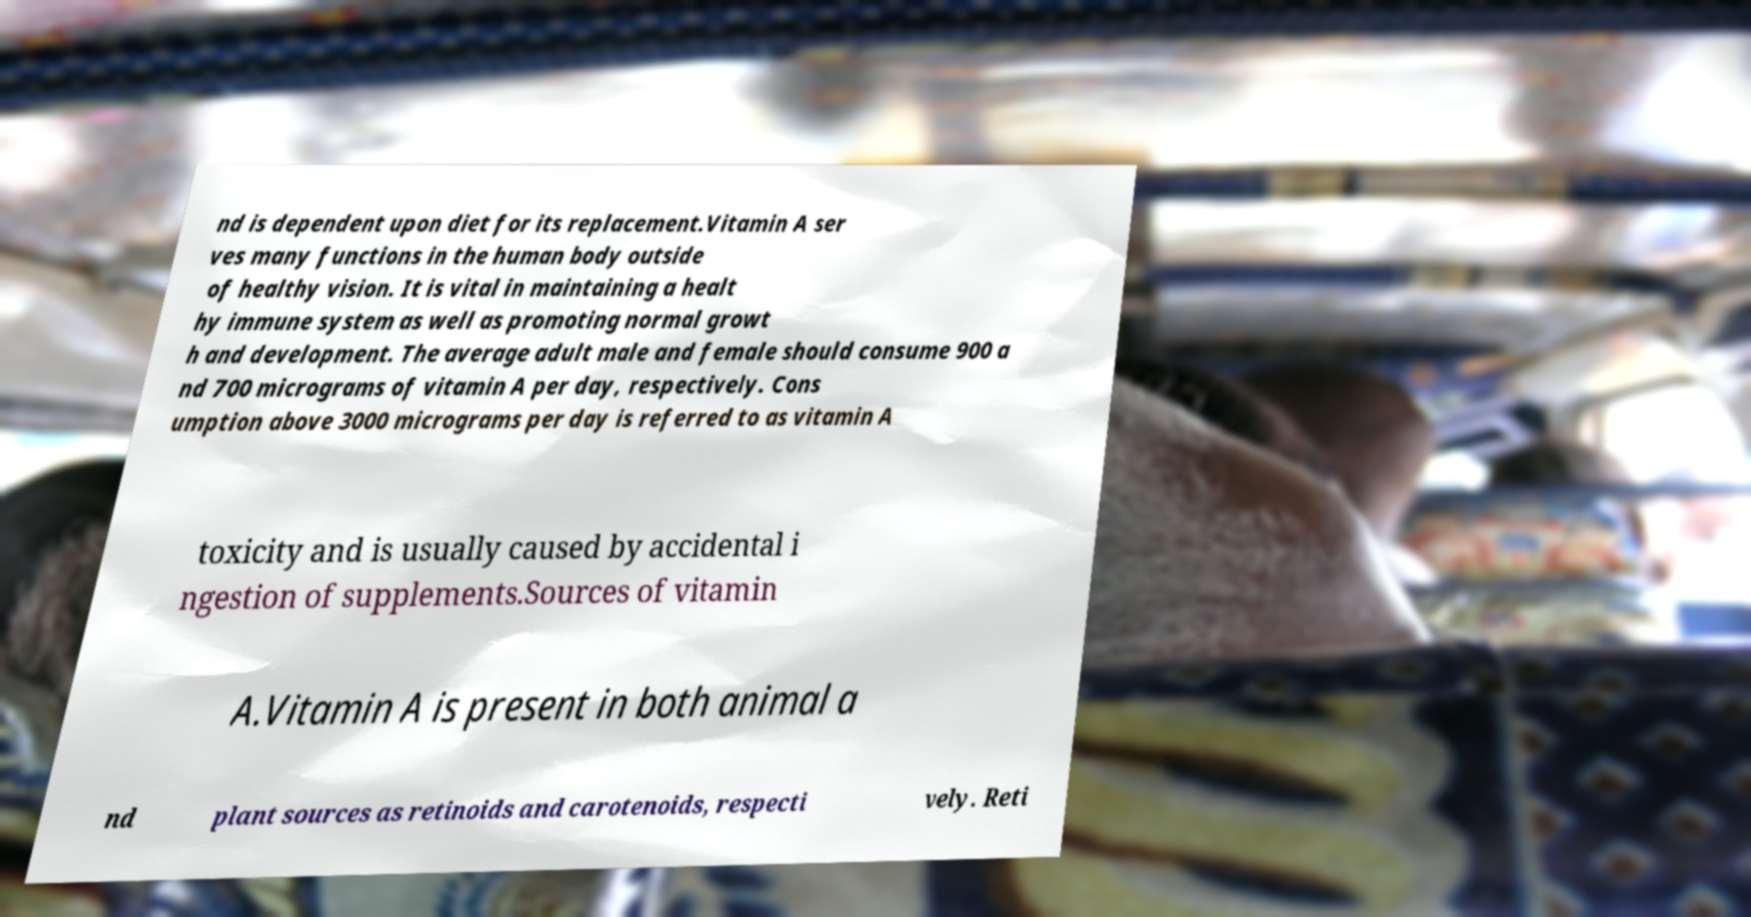Please read and relay the text visible in this image. What does it say? nd is dependent upon diet for its replacement.Vitamin A ser ves many functions in the human body outside of healthy vision. It is vital in maintaining a healt hy immune system as well as promoting normal growt h and development. The average adult male and female should consume 900 a nd 700 micrograms of vitamin A per day, respectively. Cons umption above 3000 micrograms per day is referred to as vitamin A toxicity and is usually caused by accidental i ngestion of supplements.Sources of vitamin A.Vitamin A is present in both animal a nd plant sources as retinoids and carotenoids, respecti vely. Reti 